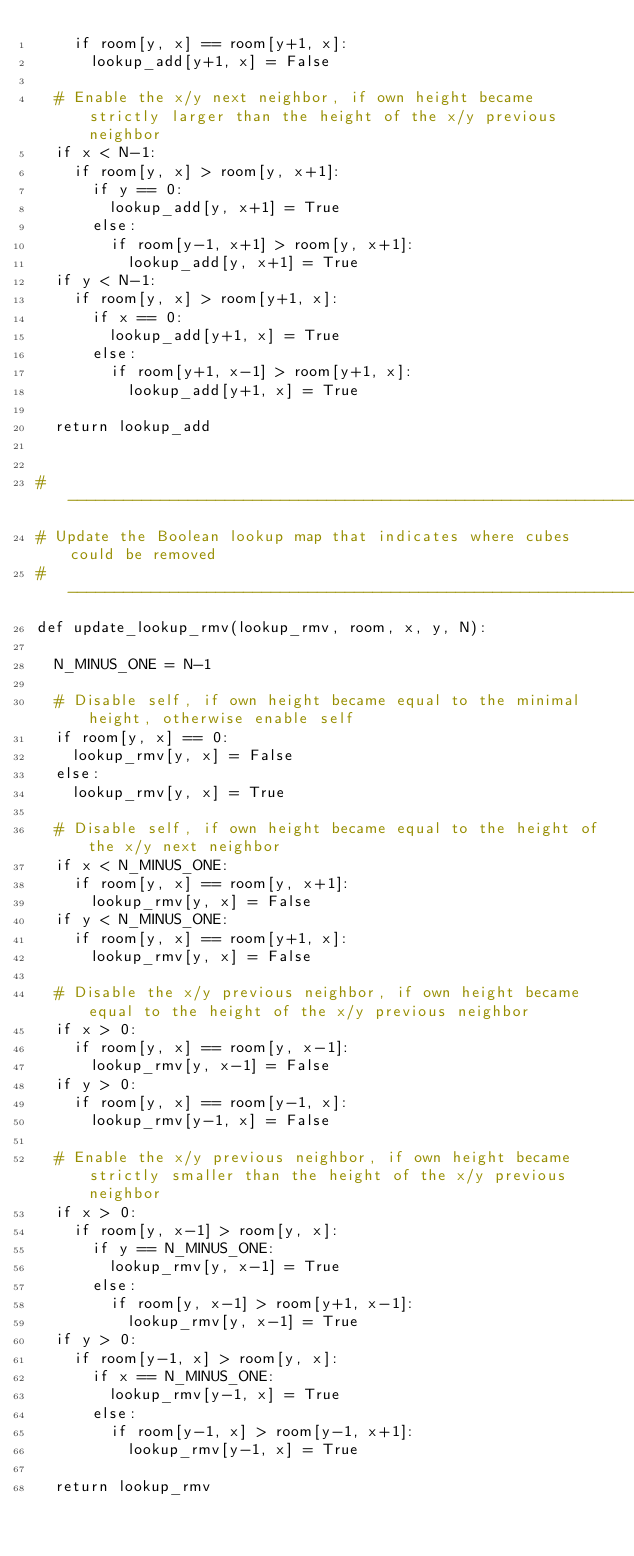<code> <loc_0><loc_0><loc_500><loc_500><_Python_>    if room[y, x] == room[y+1, x]:
      lookup_add[y+1, x] = False

  # Enable the x/y next neighbor, if own height became strictly larger than the height of the x/y previous neighbor
  if x < N-1:
    if room[y, x] > room[y, x+1]:
      if y == 0:
        lookup_add[y, x+1] = True
      else:
        if room[y-1, x+1] > room[y, x+1]:
          lookup_add[y, x+1] = True
  if y < N-1:
    if room[y, x] > room[y+1, x]:
      if x == 0:
        lookup_add[y+1, x] = True
      else:
        if room[y+1, x-1] > room[y+1, x]:
          lookup_add[y+1, x] = True

  return lookup_add


# ----------------------------------------------------------------
# Update the Boolean lookup map that indicates where cubes could be removed
# ----------------------------------------------------------------
def update_lookup_rmv(lookup_rmv, room, x, y, N):

  N_MINUS_ONE = N-1

  # Disable self, if own height became equal to the minimal height, otherwise enable self
  if room[y, x] == 0:
    lookup_rmv[y, x] = False
  else:
    lookup_rmv[y, x] = True

  # Disable self, if own height became equal to the height of the x/y next neighbor
  if x < N_MINUS_ONE:
    if room[y, x] == room[y, x+1]:
      lookup_rmv[y, x] = False
  if y < N_MINUS_ONE:
    if room[y, x] == room[y+1, x]:
      lookup_rmv[y, x] = False

  # Disable the x/y previous neighbor, if own height became equal to the height of the x/y previous neighbor
  if x > 0:
    if room[y, x] == room[y, x-1]:
      lookup_rmv[y, x-1] = False
  if y > 0:
    if room[y, x] == room[y-1, x]:
      lookup_rmv[y-1, x] = False

  # Enable the x/y previous neighbor, if own height became strictly smaller than the height of the x/y previous neighbor
  if x > 0:
    if room[y, x-1] > room[y, x]:
      if y == N_MINUS_ONE:
        lookup_rmv[y, x-1] = True
      else:
        if room[y, x-1] > room[y+1, x-1]:
          lookup_rmv[y, x-1] = True
  if y > 0:
    if room[y-1, x] > room[y, x]:
      if x == N_MINUS_ONE:
        lookup_rmv[y-1, x] = True
      else:
        if room[y-1, x] > room[y-1, x+1]:
          lookup_rmv[y-1, x] = True

  return lookup_rmv
</code> 